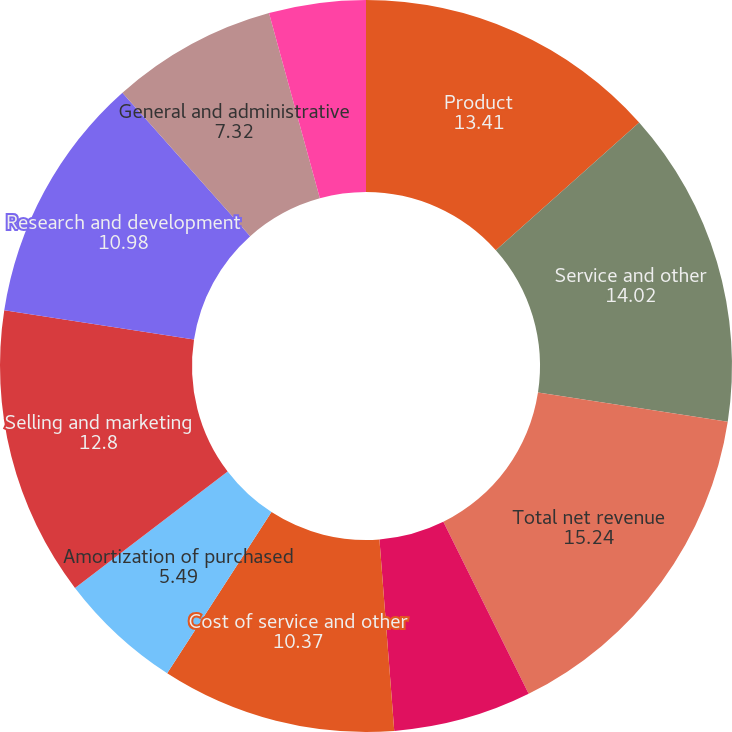Convert chart to OTSL. <chart><loc_0><loc_0><loc_500><loc_500><pie_chart><fcel>Product<fcel>Service and other<fcel>Total net revenue<fcel>Cost of product revenue<fcel>Cost of service and other<fcel>Amortization of purchased<fcel>Selling and marketing<fcel>Research and development<fcel>General and administrative<fcel>Acquisition-related charges<nl><fcel>13.41%<fcel>14.02%<fcel>15.24%<fcel>6.1%<fcel>10.37%<fcel>5.49%<fcel>12.8%<fcel>10.98%<fcel>7.32%<fcel>4.27%<nl></chart> 